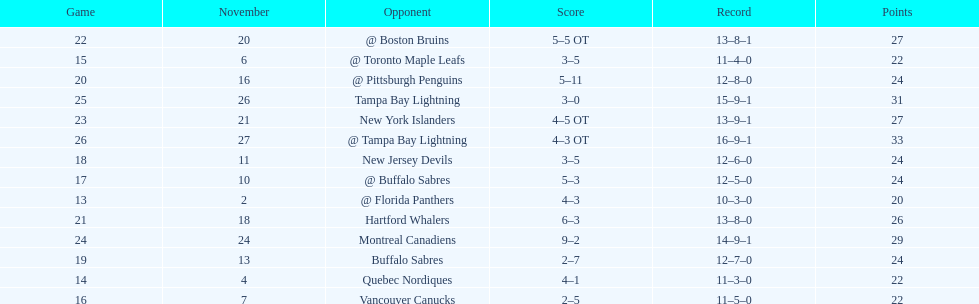Who had the most assists on the 1993-1994 flyers? Mark Recchi. 